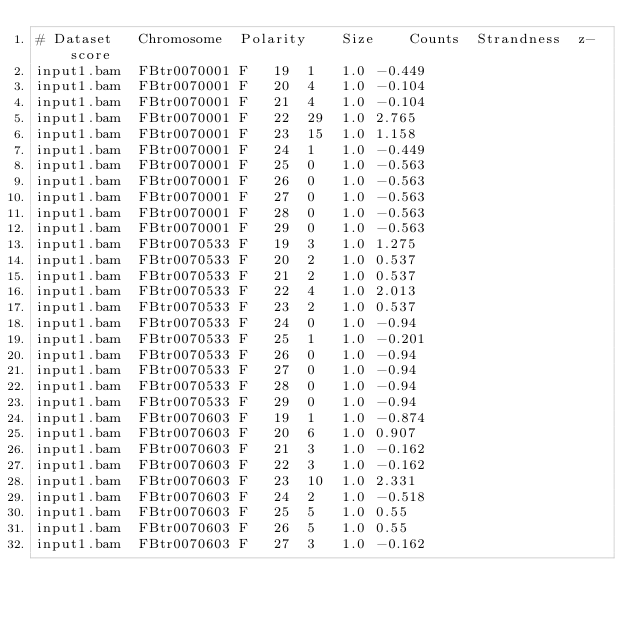<code> <loc_0><loc_0><loc_500><loc_500><_SQL_># Dataset	Chromosome	Polarity	Size	Counts	Strandness	z-score
input1.bam	FBtr0070001	F	19	1	1.0	-0.449
input1.bam	FBtr0070001	F	20	4	1.0	-0.104
input1.bam	FBtr0070001	F	21	4	1.0	-0.104
input1.bam	FBtr0070001	F	22	29	1.0	2.765
input1.bam	FBtr0070001	F	23	15	1.0	1.158
input1.bam	FBtr0070001	F	24	1	1.0	-0.449
input1.bam	FBtr0070001	F	25	0	1.0	-0.563
input1.bam	FBtr0070001	F	26	0	1.0	-0.563
input1.bam	FBtr0070001	F	27	0	1.0	-0.563
input1.bam	FBtr0070001	F	28	0	1.0	-0.563
input1.bam	FBtr0070001	F	29	0	1.0	-0.563
input1.bam	FBtr0070533	F	19	3	1.0	1.275
input1.bam	FBtr0070533	F	20	2	1.0	0.537
input1.bam	FBtr0070533	F	21	2	1.0	0.537
input1.bam	FBtr0070533	F	22	4	1.0	2.013
input1.bam	FBtr0070533	F	23	2	1.0	0.537
input1.bam	FBtr0070533	F	24	0	1.0	-0.94
input1.bam	FBtr0070533	F	25	1	1.0	-0.201
input1.bam	FBtr0070533	F	26	0	1.0	-0.94
input1.bam	FBtr0070533	F	27	0	1.0	-0.94
input1.bam	FBtr0070533	F	28	0	1.0	-0.94
input1.bam	FBtr0070533	F	29	0	1.0	-0.94
input1.bam	FBtr0070603	F	19	1	1.0	-0.874
input1.bam	FBtr0070603	F	20	6	1.0	0.907
input1.bam	FBtr0070603	F	21	3	1.0	-0.162
input1.bam	FBtr0070603	F	22	3	1.0	-0.162
input1.bam	FBtr0070603	F	23	10	1.0	2.331
input1.bam	FBtr0070603	F	24	2	1.0	-0.518
input1.bam	FBtr0070603	F	25	5	1.0	0.55
input1.bam	FBtr0070603	F	26	5	1.0	0.55
input1.bam	FBtr0070603	F	27	3	1.0	-0.162</code> 